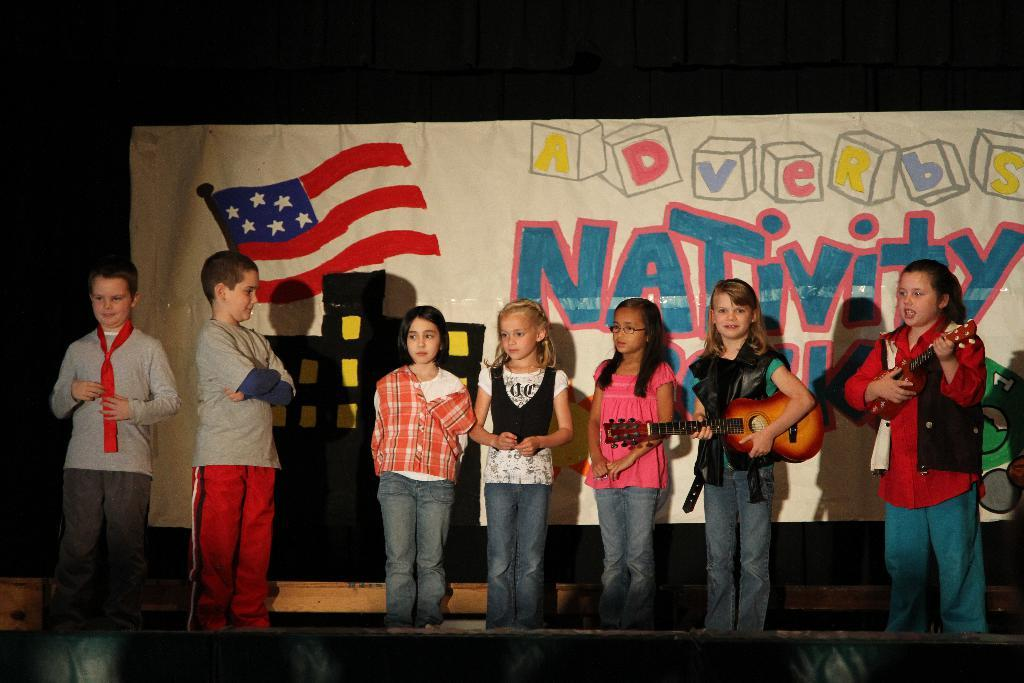How many children are present in the image? There are children in the image, but the exact number is not specified. Can you describe the position of some children in the image? Some children are standing at the left side of the image. What activity are two children engaged in the background? Two children are playing guitar in the background. What can be seen in the background besides the children playing guitar? There is a banner visible in the background. What letter is the child holding in the image? There is no child holding a letter in the image. How many beans are visible on the ground in the image? There are no beans visible in the image. 